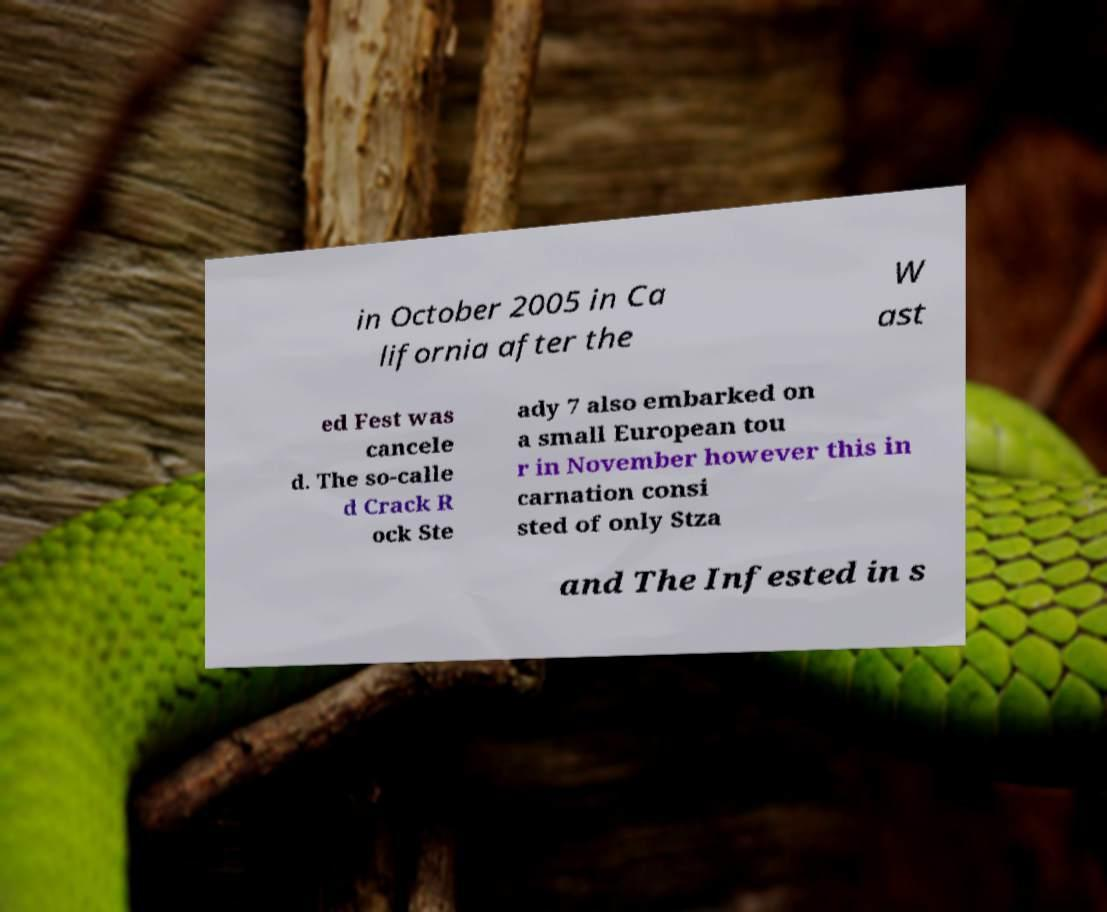Could you assist in decoding the text presented in this image and type it out clearly? in October 2005 in Ca lifornia after the W ast ed Fest was cancele d. The so-calle d Crack R ock Ste ady 7 also embarked on a small European tou r in November however this in carnation consi sted of only Stza and The Infested in s 